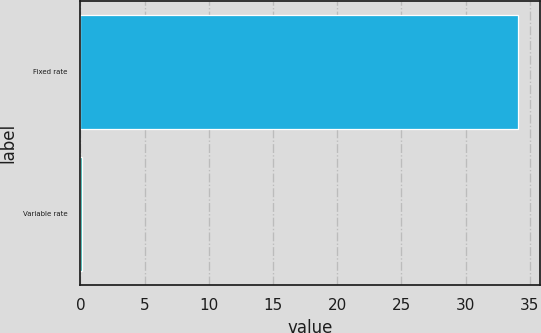<chart> <loc_0><loc_0><loc_500><loc_500><bar_chart><fcel>Fixed rate<fcel>Variable rate<nl><fcel>34.1<fcel>0.1<nl></chart> 